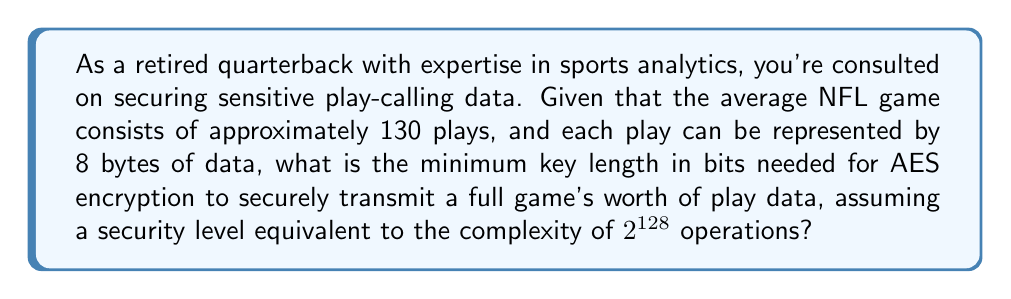Can you answer this question? To determine the optimal key length, we need to follow these steps:

1. Calculate the total amount of data to be encrypted:
   $$ \text{Total data} = 130 \text{ plays} \times 8 \text{ bytes/play} = 1040 \text{ bytes} $$

2. Convert bytes to bits:
   $$ 1040 \text{ bytes} \times 8 \text{ bits/byte} = 8320 \text{ bits} $$

3. Determine the block size for AES:
   AES uses a 128-bit block size.

4. Calculate the number of blocks needed:
   $$ \text{Number of blocks} = \lceil \frac{8320 \text{ bits}}{128 \text{ bits/block}} \rceil = 65 \text{ blocks} $$

5. Consider the security level requirement:
   We need a security level equivalent to $2^{128}$ operations.

6. Determine the minimum key length:
   For AES, the key lengths are typically 128, 192, or 256 bits.
   Given the security requirement of $2^{128}$ operations, a 128-bit key would be sufficient.

7. Verify that the key length is adequate for the data size:
   With 65 blocks, we have:
   $$ 2^{128} \gg 65 $$
   This means a 128-bit key provides more than enough security for the given data size.

Therefore, the minimum key length needed is 128 bits, which satisfies both the security requirement and the data size constraint.
Answer: 128 bits 